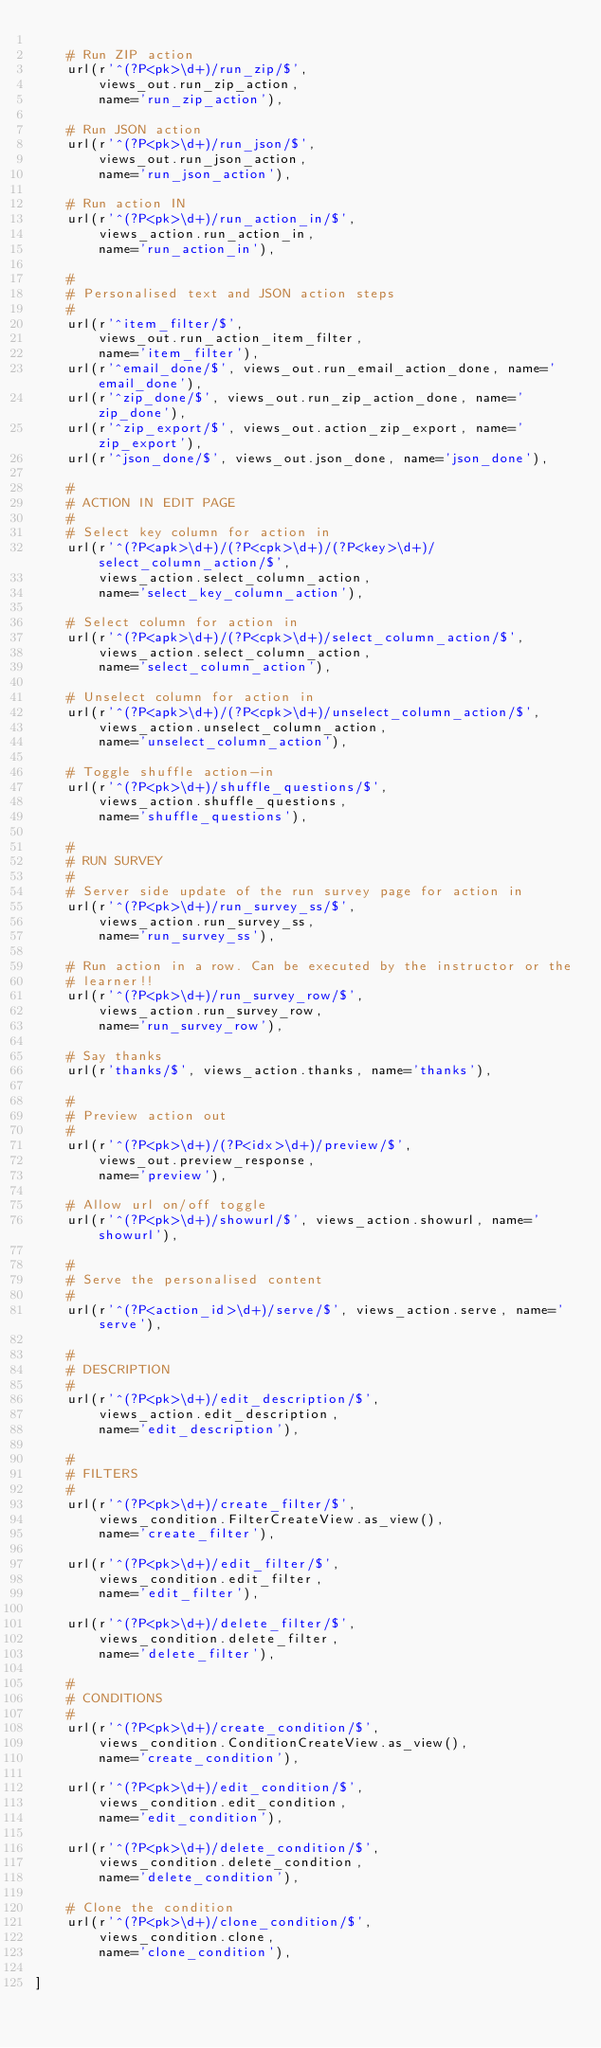<code> <loc_0><loc_0><loc_500><loc_500><_Python_>
    # Run ZIP action
    url(r'^(?P<pk>\d+)/run_zip/$',
        views_out.run_zip_action,
        name='run_zip_action'),

    # Run JSON action
    url(r'^(?P<pk>\d+)/run_json/$',
        views_out.run_json_action,
        name='run_json_action'),

    # Run action IN
    url(r'^(?P<pk>\d+)/run_action_in/$',
        views_action.run_action_in,
        name='run_action_in'),

    #
    # Personalised text and JSON action steps
    #
    url(r'^item_filter/$',
        views_out.run_action_item_filter,
        name='item_filter'),
    url(r'^email_done/$', views_out.run_email_action_done, name='email_done'),
    url(r'^zip_done/$', views_out.run_zip_action_done, name='zip_done'),
    url(r'^zip_export/$', views_out.action_zip_export, name='zip_export'),
    url(r'^json_done/$', views_out.json_done, name='json_done'),

    #
    # ACTION IN EDIT PAGE
    #
    # Select key column for action in
    url(r'^(?P<apk>\d+)/(?P<cpk>\d+)/(?P<key>\d+)/select_column_action/$',
        views_action.select_column_action,
        name='select_key_column_action'),

    # Select column for action in
    url(r'^(?P<apk>\d+)/(?P<cpk>\d+)/select_column_action/$',
        views_action.select_column_action,
        name='select_column_action'),

    # Unselect column for action in
    url(r'^(?P<apk>\d+)/(?P<cpk>\d+)/unselect_column_action/$',
        views_action.unselect_column_action,
        name='unselect_column_action'),

    # Toggle shuffle action-in
    url(r'^(?P<pk>\d+)/shuffle_questions/$',
        views_action.shuffle_questions,
        name='shuffle_questions'),

    #
    # RUN SURVEY
    #
    # Server side update of the run survey page for action in
    url(r'^(?P<pk>\d+)/run_survey_ss/$',
        views_action.run_survey_ss,
        name='run_survey_ss'),

    # Run action in a row. Can be executed by the instructor or the
    # learner!!
    url(r'^(?P<pk>\d+)/run_survey_row/$',
        views_action.run_survey_row,
        name='run_survey_row'),

    # Say thanks
    url(r'thanks/$', views_action.thanks, name='thanks'),

    #
    # Preview action out
    #
    url(r'^(?P<pk>\d+)/(?P<idx>\d+)/preview/$',
        views_out.preview_response,
        name='preview'),

    # Allow url on/off toggle
    url(r'^(?P<pk>\d+)/showurl/$', views_action.showurl, name='showurl'),

    #
    # Serve the personalised content
    #
    url(r'^(?P<action_id>\d+)/serve/$', views_action.serve, name='serve'),

    #
    # DESCRIPTION
    #
    url(r'^(?P<pk>\d+)/edit_description/$',
        views_action.edit_description,
        name='edit_description'),

    #
    # FILTERS
    #
    url(r'^(?P<pk>\d+)/create_filter/$',
        views_condition.FilterCreateView.as_view(),
        name='create_filter'),

    url(r'^(?P<pk>\d+)/edit_filter/$',
        views_condition.edit_filter,
        name='edit_filter'),

    url(r'^(?P<pk>\d+)/delete_filter/$',
        views_condition.delete_filter,
        name='delete_filter'),

    #
    # CONDITIONS
    #
    url(r'^(?P<pk>\d+)/create_condition/$',
        views_condition.ConditionCreateView.as_view(),
        name='create_condition'),

    url(r'^(?P<pk>\d+)/edit_condition/$',
        views_condition.edit_condition,
        name='edit_condition'),

    url(r'^(?P<pk>\d+)/delete_condition/$',
        views_condition.delete_condition,
        name='delete_condition'),

    # Clone the condition
    url(r'^(?P<pk>\d+)/clone_condition/$',
        views_condition.clone,
        name='clone_condition'),

]
</code> 